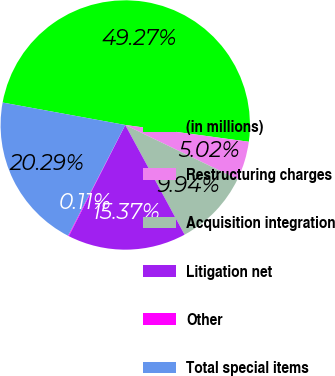Convert chart. <chart><loc_0><loc_0><loc_500><loc_500><pie_chart><fcel>(in millions)<fcel>Restructuring charges<fcel>Acquisition integration<fcel>Litigation net<fcel>Other<fcel>Total special items<nl><fcel>49.27%<fcel>5.02%<fcel>9.94%<fcel>15.37%<fcel>0.11%<fcel>20.29%<nl></chart> 